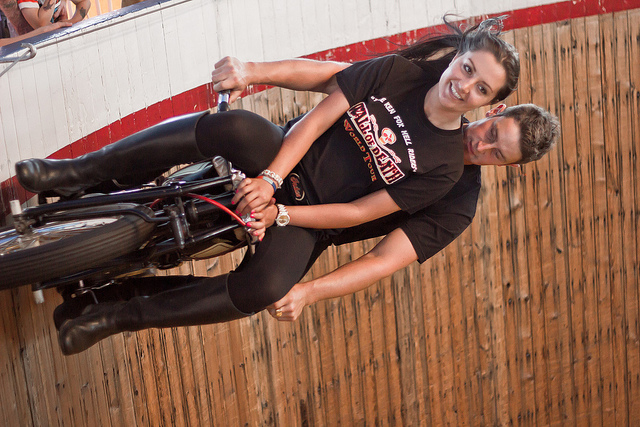Please extract the text content from this image. ken POX WORLD TOUR 